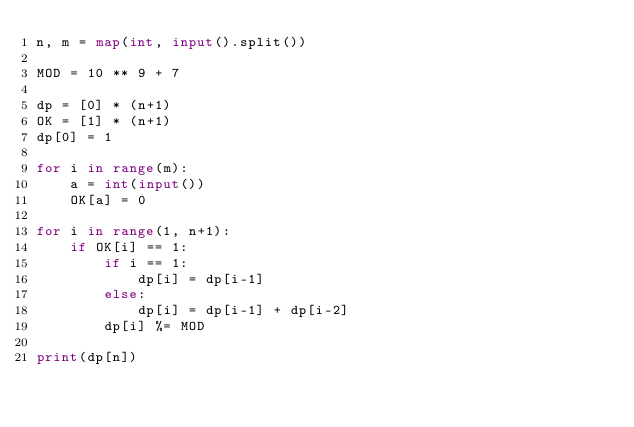Convert code to text. <code><loc_0><loc_0><loc_500><loc_500><_Python_>n, m = map(int, input().split())

MOD = 10 ** 9 + 7

dp = [0] * (n+1)
OK = [1] * (n+1)
dp[0] = 1

for i in range(m):
    a = int(input())
    OK[a] = 0

for i in range(1, n+1):
    if OK[i] == 1:
        if i == 1:
            dp[i] = dp[i-1]
        else:
            dp[i] = dp[i-1] + dp[i-2]
        dp[i] %= MOD

print(dp[n])</code> 